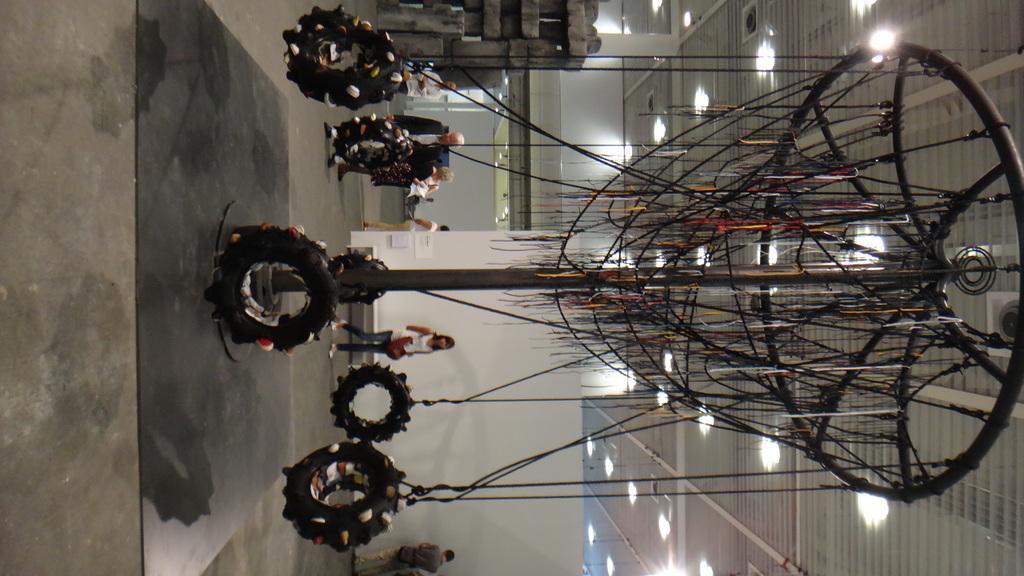Can you describe this image briefly? We can see tires with ropes. Background we can see people and wall. Top we can see lights. 